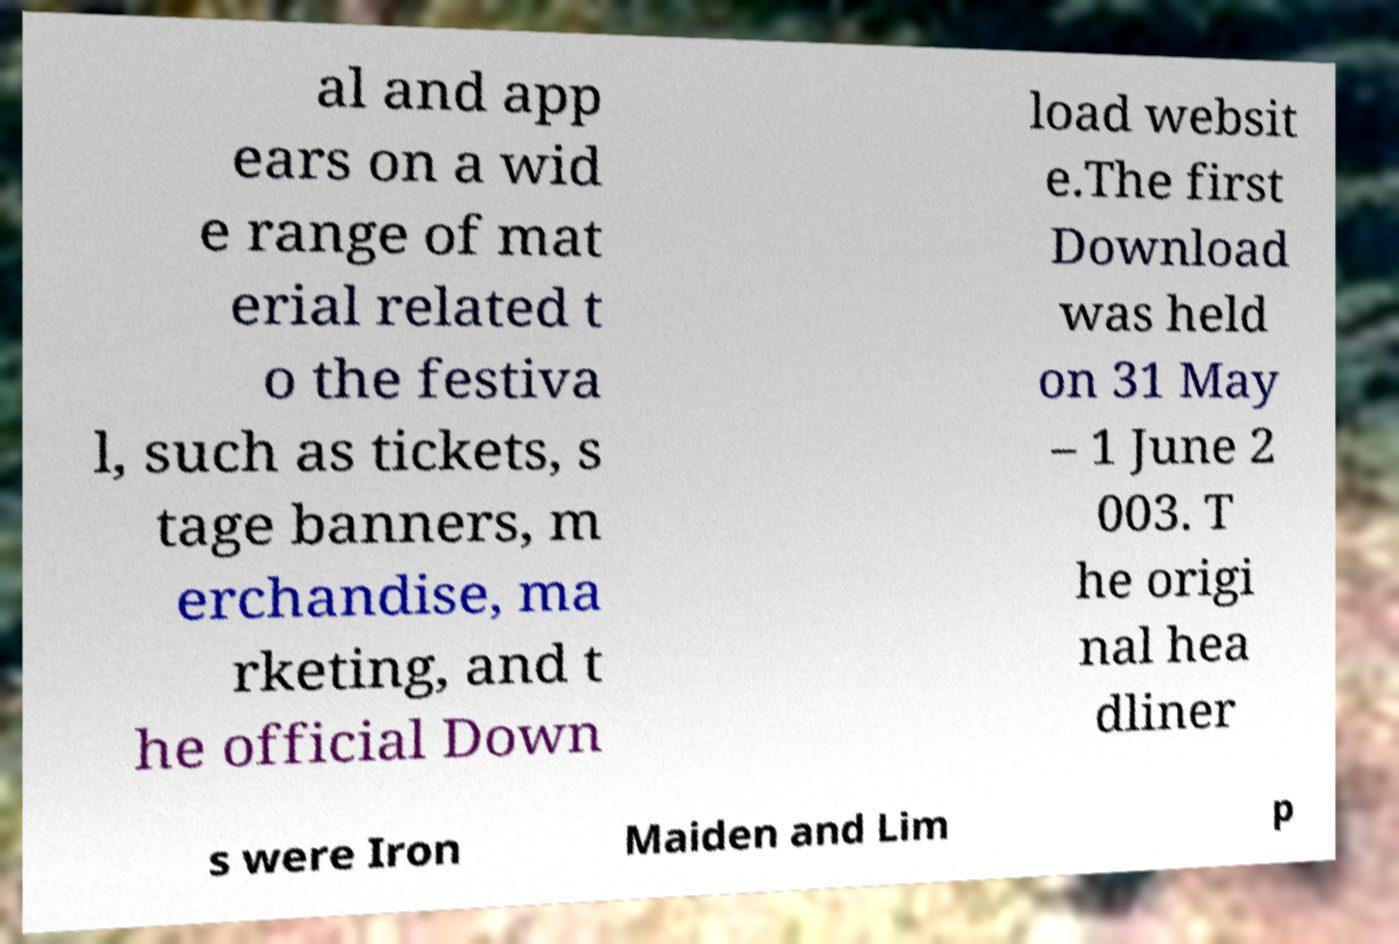Could you extract and type out the text from this image? al and app ears on a wid e range of mat erial related t o the festiva l, such as tickets, s tage banners, m erchandise, ma rketing, and t he official Down load websit e.The first Download was held on 31 May – 1 June 2 003. T he origi nal hea dliner s were Iron Maiden and Lim p 